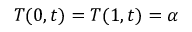<formula> <loc_0><loc_0><loc_500><loc_500>T ( 0 , t ) = T ( 1 , t ) = \alpha</formula> 